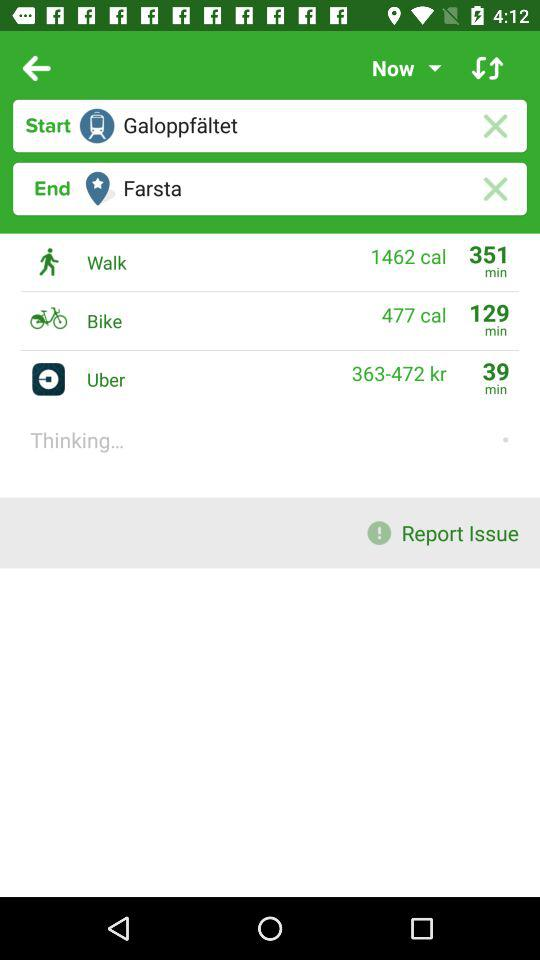What is the end point? The end point is "Farsta". 